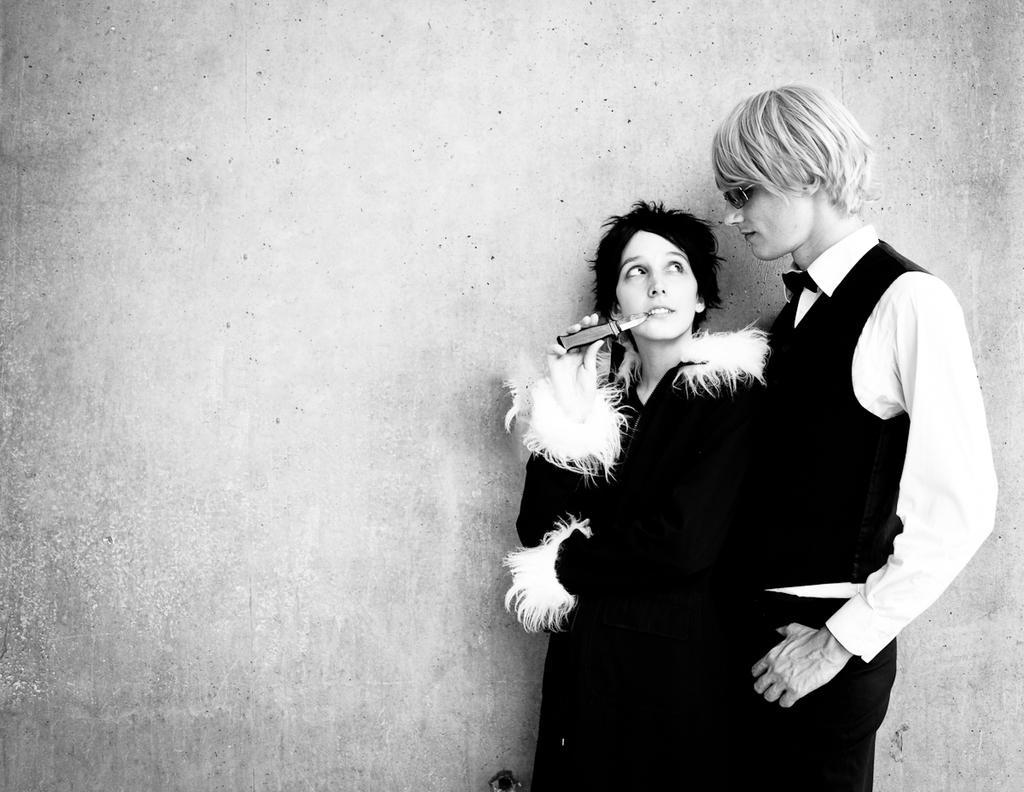In one or two sentences, can you explain what this image depicts? In this picture I can observe a couple on the right side. In the background I can observe wall. This is a black and white image. 